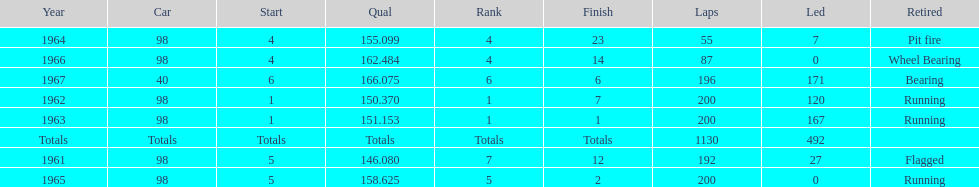How many consecutive years did parnelli place in the top 5? 5. 